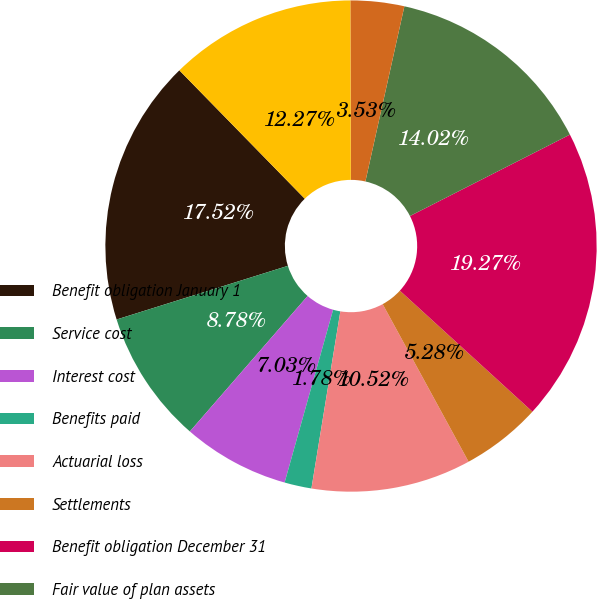<chart> <loc_0><loc_0><loc_500><loc_500><pie_chart><fcel>Benefit obligation January 1<fcel>Service cost<fcel>Interest cost<fcel>Benefits paid<fcel>Actuarial loss<fcel>Settlements<fcel>Benefit obligation December 31<fcel>Fair value of plan assets<fcel>Actual return on plan assets<fcel>Employer contributions<nl><fcel>17.52%<fcel>8.78%<fcel>7.03%<fcel>1.78%<fcel>10.52%<fcel>5.28%<fcel>19.27%<fcel>14.02%<fcel>3.53%<fcel>12.27%<nl></chart> 